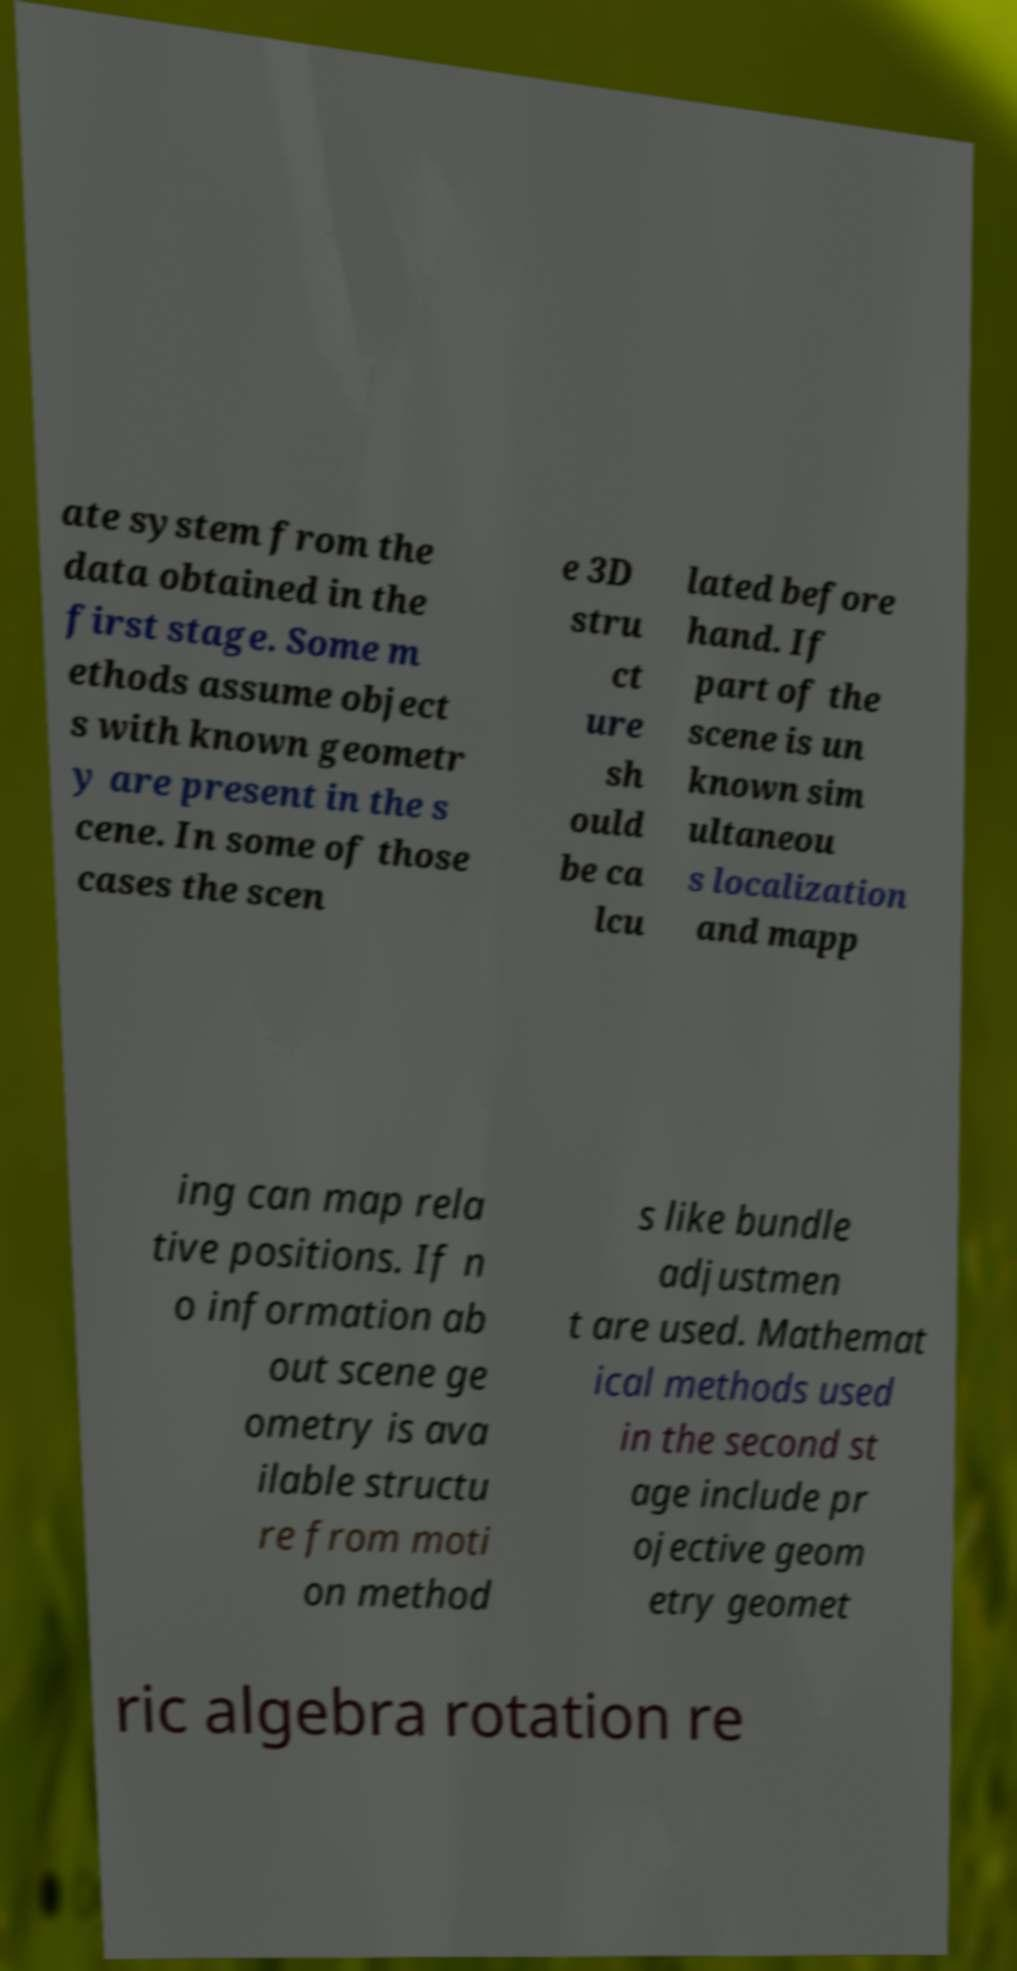Can you read and provide the text displayed in the image?This photo seems to have some interesting text. Can you extract and type it out for me? ate system from the data obtained in the first stage. Some m ethods assume object s with known geometr y are present in the s cene. In some of those cases the scen e 3D stru ct ure sh ould be ca lcu lated before hand. If part of the scene is un known sim ultaneou s localization and mapp ing can map rela tive positions. If n o information ab out scene ge ometry is ava ilable structu re from moti on method s like bundle adjustmen t are used. Mathemat ical methods used in the second st age include pr ojective geom etry geomet ric algebra rotation re 